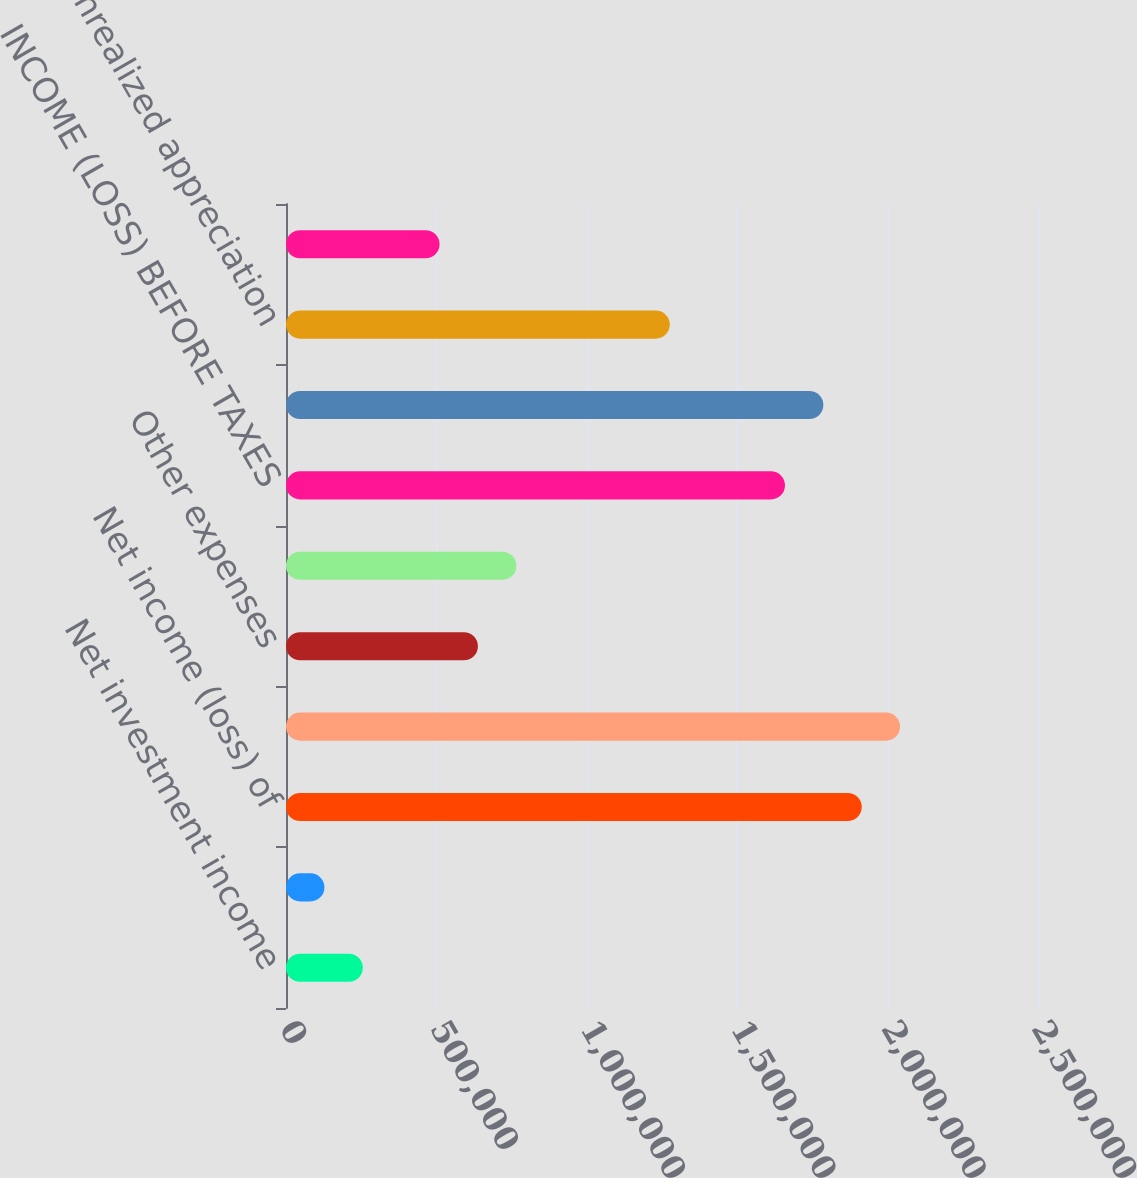<chart> <loc_0><loc_0><loc_500><loc_500><bar_chart><fcel>Net investment income<fcel>Other income (expense)<fcel>Net income (loss) of<fcel>Total revenues<fcel>Other expenses<fcel>Total expenses<fcel>INCOME (LOSS) BEFORE TAXES<fcel>NET INCOME (LOSS)<fcel>Unrealized appreciation<fcel>Reclassification adjustment<nl><fcel>255337<fcel>127749<fcel>1.91397e+06<fcel>2.04156e+06<fcel>638098<fcel>765686<fcel>1.6588e+06<fcel>1.78638e+06<fcel>1.27604e+06<fcel>510511<nl></chart> 